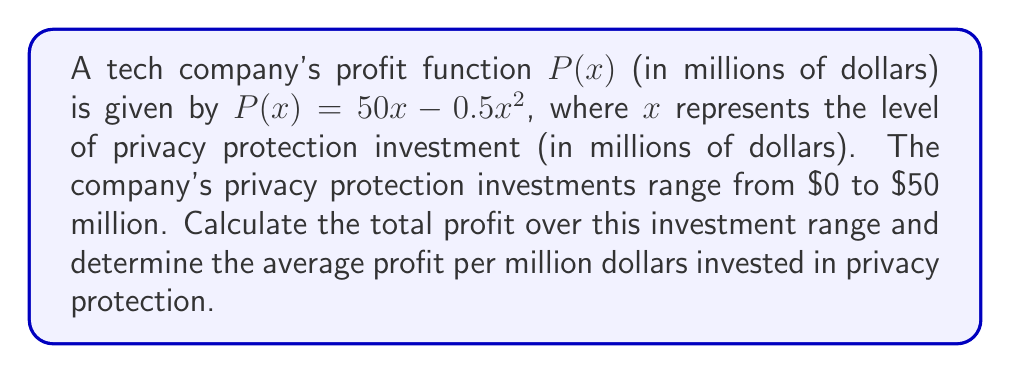Help me with this question. To solve this problem, we need to follow these steps:

1) First, we need to find the total profit by integrating the profit function over the given range of investments.

   Total Profit = $\int_{0}^{50} P(x) dx = \int_{0}^{50} (50x - 0.5x^2) dx$

2) Let's solve this integral:

   $\int_{0}^{50} (50x - 0.5x^2) dx = [25x^2 - \frac{1}{6}x^3]_{0}^{50}$

3) Evaluate the integral:

   $= (25(50)^2 - \frac{1}{6}(50)^3) - (25(0)^2 - \frac{1}{6}(0)^3)$
   $= (62500 - 20833.33) - 0$
   $= 41666.67$ million dollars

4) To find the average profit per million dollars invested, we need to divide the total profit by the range of investment:

   Average Profit = Total Profit / Investment Range
                  = $41666.67 / (50 - 0)$
                  = $833.33$ million dollars per million invested

Therefore, the total profit over the investment range is $41666.67 million, and the average profit per million dollars invested in privacy protection is $833.33 million.
Answer: Total Profit: $41666.67 million
Average Profit per million invested: $833.33 million 